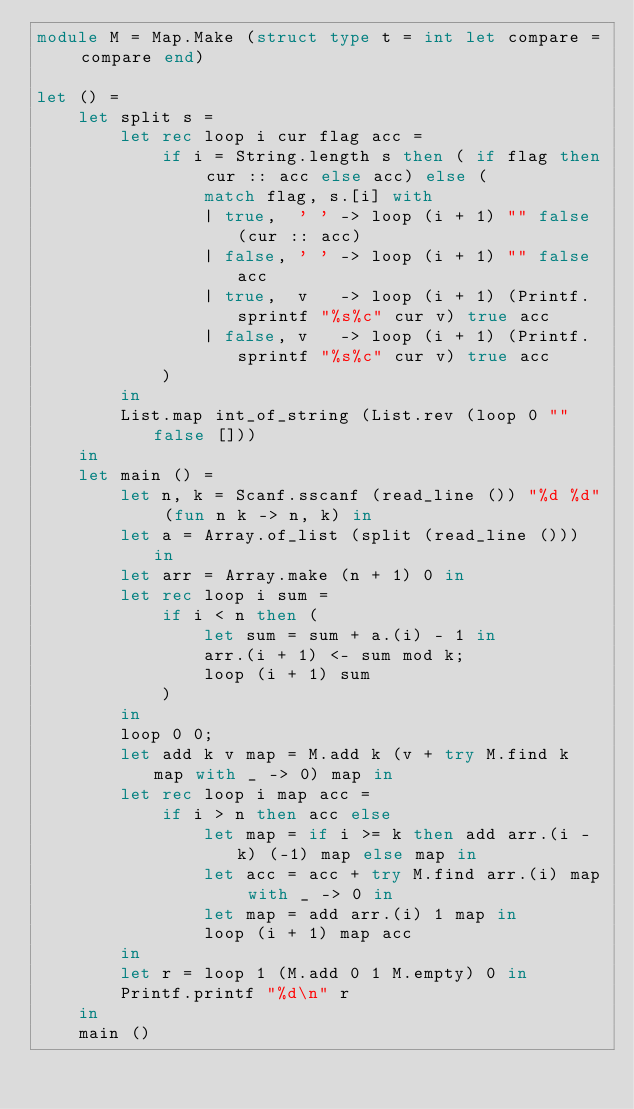Convert code to text. <code><loc_0><loc_0><loc_500><loc_500><_OCaml_>module M = Map.Make (struct type t = int let compare = compare end)

let () =
    let split s =
        let rec loop i cur flag acc =
            if i = String.length s then ( if flag then cur :: acc else acc) else (
                match flag, s.[i] with
                | true,  ' ' -> loop (i + 1) "" false (cur :: acc)
                | false, ' ' -> loop (i + 1) "" false acc
                | true,  v   -> loop (i + 1) (Printf.sprintf "%s%c" cur v) true acc
                | false, v   -> loop (i + 1) (Printf.sprintf "%s%c" cur v) true acc
            )
        in
        List.map int_of_string (List.rev (loop 0 "" false []))
    in
    let main () =
        let n, k = Scanf.sscanf (read_line ()) "%d %d" (fun n k -> n, k) in
        let a = Array.of_list (split (read_line ())) in
        let arr = Array.make (n + 1) 0 in
        let rec loop i sum =
            if i < n then (
                let sum = sum + a.(i) - 1 in
                arr.(i + 1) <- sum mod k;
                loop (i + 1) sum
            )
        in
        loop 0 0;
        let add k v map = M.add k (v + try M.find k map with _ -> 0) map in
        let rec loop i map acc =
            if i > n then acc else
                let map = if i >= k then add arr.(i - k) (-1) map else map in
                let acc = acc + try M.find arr.(i) map with _ -> 0 in
                let map = add arr.(i) 1 map in
                loop (i + 1) map acc
        in
        let r = loop 1 (M.add 0 1 M.empty) 0 in
        Printf.printf "%d\n" r
    in
    main ()</code> 